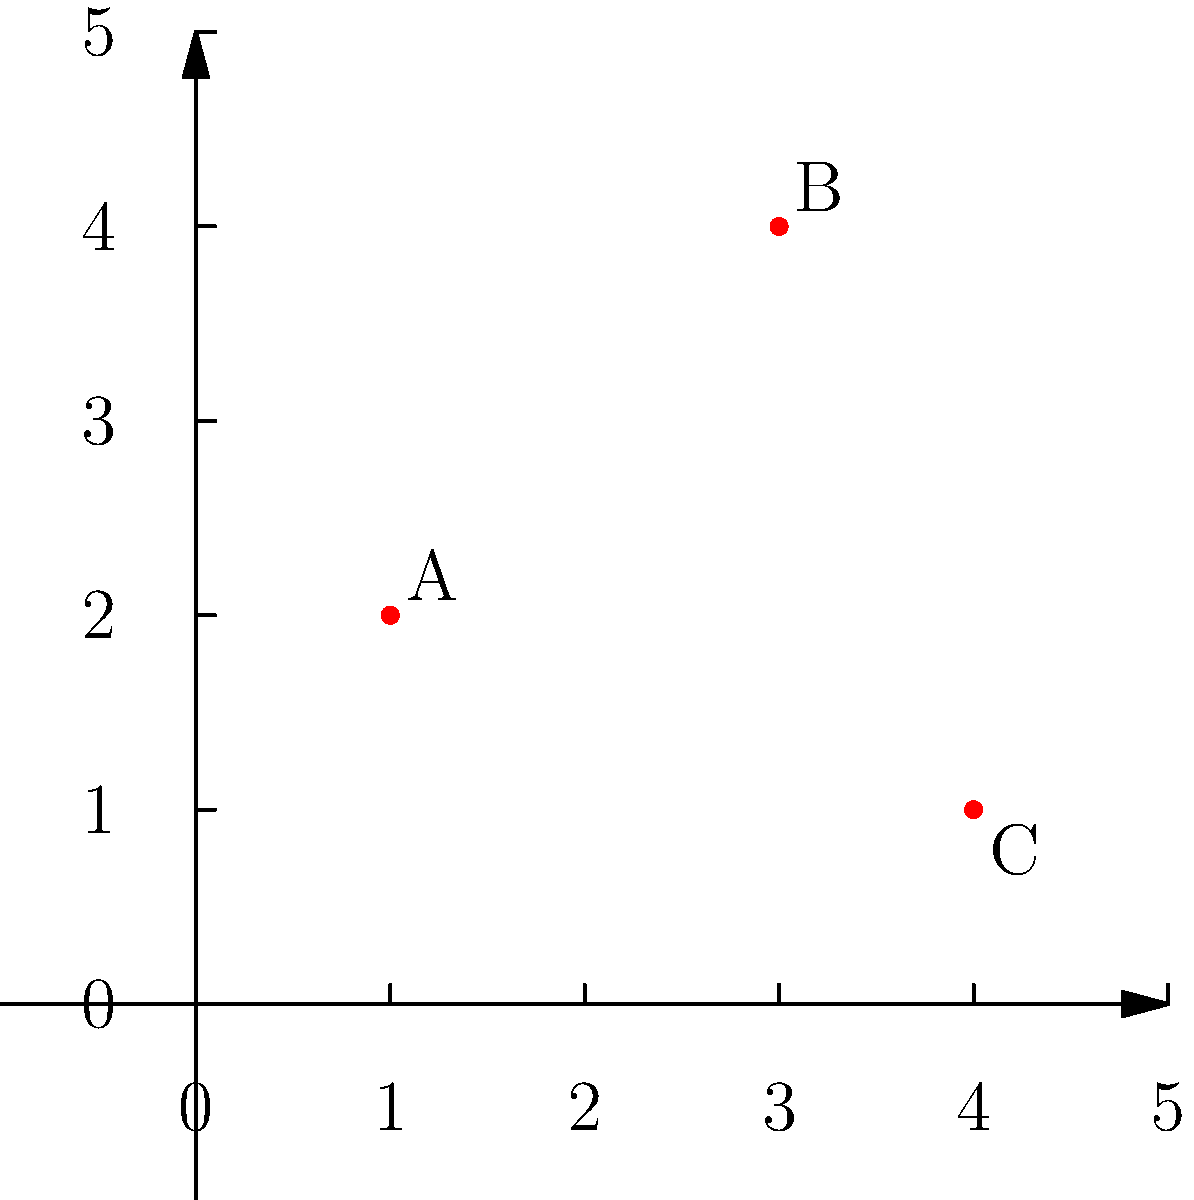In the coordinate plane above, three points A, B, and C represent the locations of historic football grounds in Uphall. If these points form a triangle, what is the area of this triangle? To find the area of the triangle formed by points A(1,2), B(3,4), and C(4,1), we can use the formula for the area of a triangle given the coordinates of its vertices:

Area = $\frac{1}{2}|x_1(y_2 - y_3) + x_2(y_3 - y_1) + x_3(y_1 - y_2)|$

Where $(x_1,y_1)$, $(x_2,y_2)$, and $(x_3,y_3)$ are the coordinates of the three points.

Step 1: Substitute the coordinates into the formula:
Area = $\frac{1}{2}|1(4 - 1) + 3(1 - 2) + 4(2 - 4)|$

Step 2: Simplify the expressions inside the parentheses:
Area = $\frac{1}{2}|1(3) + 3(-1) + 4(-2)|$

Step 3: Multiply:
Area = $\frac{1}{2}|3 - 3 - 8|$

Step 4: Add the terms inside the absolute value signs:
Area = $\frac{1}{2}|-8|$

Step 5: Simplify:
Area = $\frac{1}{2}(8) = 4$

Therefore, the area of the triangle formed by the three historic football grounds is 4 square units.
Answer: 4 square units 